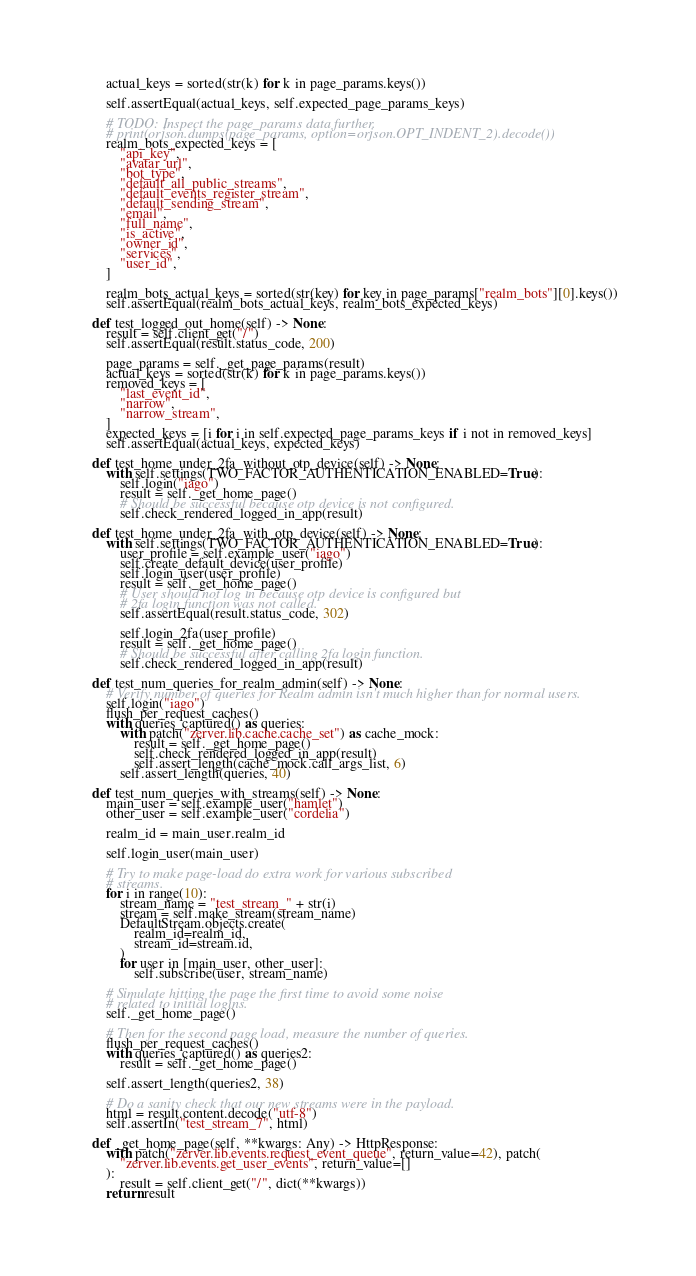<code> <loc_0><loc_0><loc_500><loc_500><_Python_>        actual_keys = sorted(str(k) for k in page_params.keys())

        self.assertEqual(actual_keys, self.expected_page_params_keys)

        # TODO: Inspect the page_params data further.
        # print(orjson.dumps(page_params, option=orjson.OPT_INDENT_2).decode())
        realm_bots_expected_keys = [
            "api_key",
            "avatar_url",
            "bot_type",
            "default_all_public_streams",
            "default_events_register_stream",
            "default_sending_stream",
            "email",
            "full_name",
            "is_active",
            "owner_id",
            "services",
            "user_id",
        ]

        realm_bots_actual_keys = sorted(str(key) for key in page_params["realm_bots"][0].keys())
        self.assertEqual(realm_bots_actual_keys, realm_bots_expected_keys)

    def test_logged_out_home(self) -> None:
        result = self.client_get("/")
        self.assertEqual(result.status_code, 200)

        page_params = self._get_page_params(result)
        actual_keys = sorted(str(k) for k in page_params.keys())
        removed_keys = [
            "last_event_id",
            "narrow",
            "narrow_stream",
        ]
        expected_keys = [i for i in self.expected_page_params_keys if i not in removed_keys]
        self.assertEqual(actual_keys, expected_keys)

    def test_home_under_2fa_without_otp_device(self) -> None:
        with self.settings(TWO_FACTOR_AUTHENTICATION_ENABLED=True):
            self.login("iago")
            result = self._get_home_page()
            # Should be successful because otp device is not configured.
            self.check_rendered_logged_in_app(result)

    def test_home_under_2fa_with_otp_device(self) -> None:
        with self.settings(TWO_FACTOR_AUTHENTICATION_ENABLED=True):
            user_profile = self.example_user("iago")
            self.create_default_device(user_profile)
            self.login_user(user_profile)
            result = self._get_home_page()
            # User should not log in because otp device is configured but
            # 2fa login function was not called.
            self.assertEqual(result.status_code, 302)

            self.login_2fa(user_profile)
            result = self._get_home_page()
            # Should be successful after calling 2fa login function.
            self.check_rendered_logged_in_app(result)

    def test_num_queries_for_realm_admin(self) -> None:
        # Verify number of queries for Realm admin isn't much higher than for normal users.
        self.login("iago")
        flush_per_request_caches()
        with queries_captured() as queries:
            with patch("zerver.lib.cache.cache_set") as cache_mock:
                result = self._get_home_page()
                self.check_rendered_logged_in_app(result)
                self.assert_length(cache_mock.call_args_list, 6)
            self.assert_length(queries, 40)

    def test_num_queries_with_streams(self) -> None:
        main_user = self.example_user("hamlet")
        other_user = self.example_user("cordelia")

        realm_id = main_user.realm_id

        self.login_user(main_user)

        # Try to make page-load do extra work for various subscribed
        # streams.
        for i in range(10):
            stream_name = "test_stream_" + str(i)
            stream = self.make_stream(stream_name)
            DefaultStream.objects.create(
                realm_id=realm_id,
                stream_id=stream.id,
            )
            for user in [main_user, other_user]:
                self.subscribe(user, stream_name)

        # Simulate hitting the page the first time to avoid some noise
        # related to initial logins.
        self._get_home_page()

        # Then for the second page load, measure the number of queries.
        flush_per_request_caches()
        with queries_captured() as queries2:
            result = self._get_home_page()

        self.assert_length(queries2, 38)

        # Do a sanity check that our new streams were in the payload.
        html = result.content.decode("utf-8")
        self.assertIn("test_stream_7", html)

    def _get_home_page(self, **kwargs: Any) -> HttpResponse:
        with patch("zerver.lib.events.request_event_queue", return_value=42), patch(
            "zerver.lib.events.get_user_events", return_value=[]
        ):
            result = self.client_get("/", dict(**kwargs))
        return result
</code> 